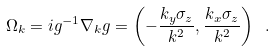Convert formula to latex. <formula><loc_0><loc_0><loc_500><loc_500>\Omega _ { k } = i g ^ { - 1 } \nabla _ { k } g = \left ( - \frac { k _ { y } \sigma _ { z } } { k ^ { 2 } } , \frac { k _ { x } \sigma _ { z } } { k ^ { 2 } } \right ) \ .</formula> 